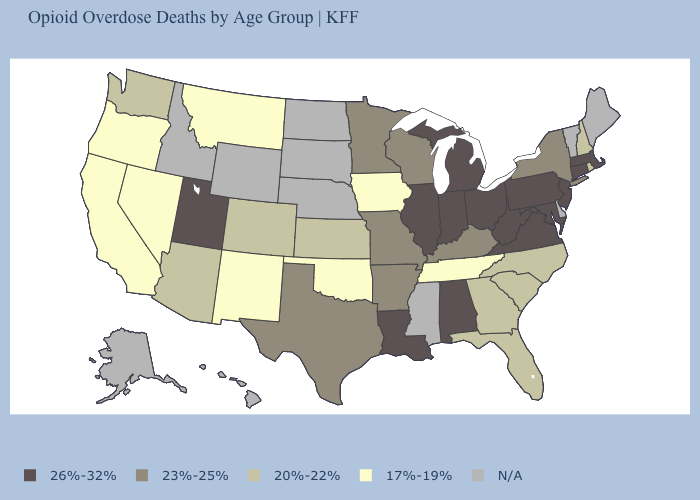Which states have the highest value in the USA?
Concise answer only. Alabama, Connecticut, Illinois, Indiana, Louisiana, Maryland, Massachusetts, Michigan, New Jersey, Ohio, Pennsylvania, Utah, Virginia, West Virginia. Among the states that border West Virginia , does Maryland have the highest value?
Short answer required. Yes. What is the value of New York?
Quick response, please. 23%-25%. What is the lowest value in the West?
Give a very brief answer. 17%-19%. Among the states that border Wisconsin , which have the highest value?
Answer briefly. Illinois, Michigan. Is the legend a continuous bar?
Write a very short answer. No. Which states hav the highest value in the South?
Write a very short answer. Alabama, Louisiana, Maryland, Virginia, West Virginia. Which states have the lowest value in the USA?
Concise answer only. California, Iowa, Montana, Nevada, New Mexico, Oklahoma, Oregon, Tennessee. What is the value of Iowa?
Answer briefly. 17%-19%. Which states hav the highest value in the South?
Short answer required. Alabama, Louisiana, Maryland, Virginia, West Virginia. Does the first symbol in the legend represent the smallest category?
Keep it brief. No. Does the map have missing data?
Be succinct. Yes. Name the states that have a value in the range 26%-32%?
Give a very brief answer. Alabama, Connecticut, Illinois, Indiana, Louisiana, Maryland, Massachusetts, Michigan, New Jersey, Ohio, Pennsylvania, Utah, Virginia, West Virginia. What is the lowest value in states that border Massachusetts?
Concise answer only. 20%-22%. 